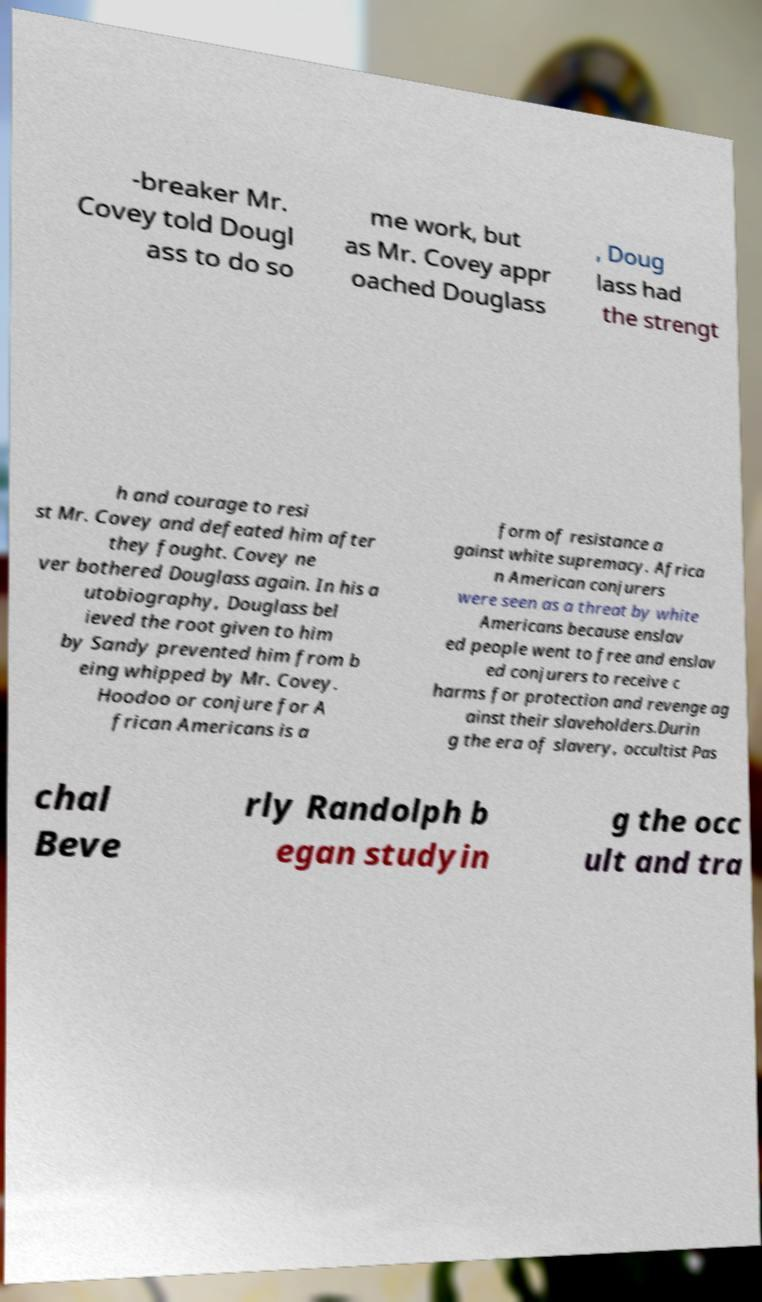Can you accurately transcribe the text from the provided image for me? -breaker Mr. Covey told Dougl ass to do so me work, but as Mr. Covey appr oached Douglass , Doug lass had the strengt h and courage to resi st Mr. Covey and defeated him after they fought. Covey ne ver bothered Douglass again. In his a utobiography, Douglass bel ieved the root given to him by Sandy prevented him from b eing whipped by Mr. Covey. Hoodoo or conjure for A frican Americans is a form of resistance a gainst white supremacy. Africa n American conjurers were seen as a threat by white Americans because enslav ed people went to free and enslav ed conjurers to receive c harms for protection and revenge ag ainst their slaveholders.Durin g the era of slavery, occultist Pas chal Beve rly Randolph b egan studyin g the occ ult and tra 